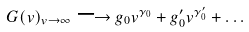Convert formula to latex. <formula><loc_0><loc_0><loc_500><loc_500>G ( v ) _ { v \to \infty } \longrightarrow g _ { 0 } v ^ { \gamma _ { 0 } } + g _ { 0 } ^ { \prime } v ^ { \gamma _ { 0 } ^ { \prime } } + \dots</formula> 